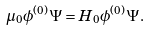Convert formula to latex. <formula><loc_0><loc_0><loc_500><loc_500>\mu _ { 0 } \phi ^ { ( 0 ) } \Psi = H _ { 0 } \phi ^ { ( 0 ) } \Psi .</formula> 